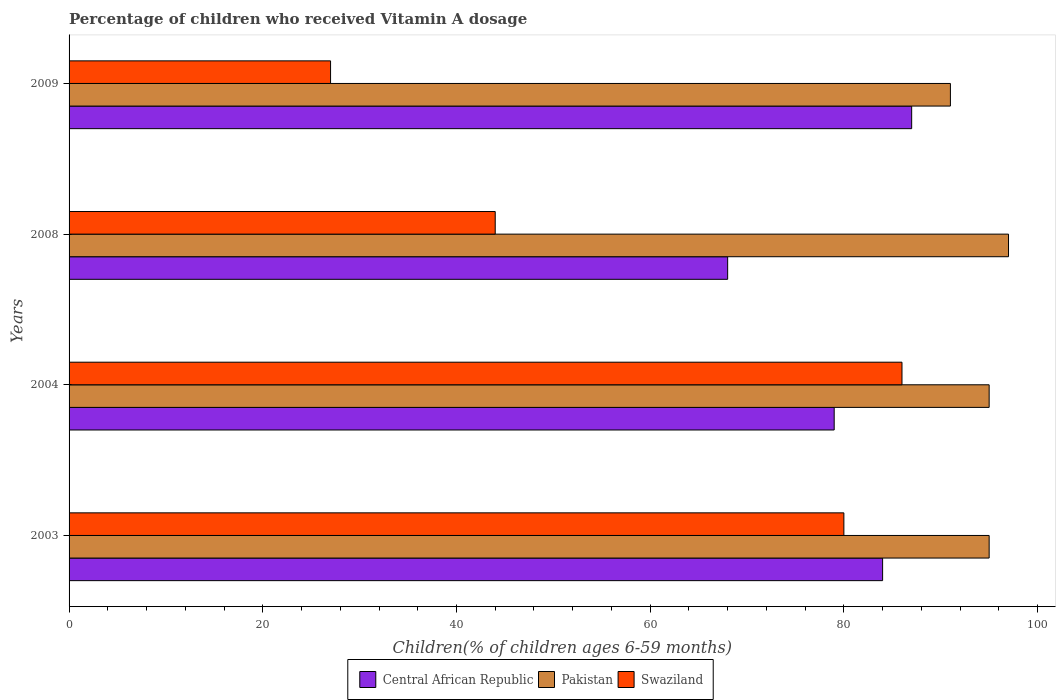In how many cases, is the number of bars for a given year not equal to the number of legend labels?
Give a very brief answer. 0. Across all years, what is the maximum percentage of children who received Vitamin A dosage in Pakistan?
Provide a succinct answer. 97. Across all years, what is the minimum percentage of children who received Vitamin A dosage in Central African Republic?
Offer a terse response. 68. What is the total percentage of children who received Vitamin A dosage in Central African Republic in the graph?
Offer a terse response. 318. What is the difference between the percentage of children who received Vitamin A dosage in Pakistan in 2003 and that in 2008?
Your answer should be very brief. -2. What is the average percentage of children who received Vitamin A dosage in Pakistan per year?
Ensure brevity in your answer.  94.5. In how many years, is the percentage of children who received Vitamin A dosage in Pakistan greater than 24 %?
Offer a very short reply. 4. What is the ratio of the percentage of children who received Vitamin A dosage in Pakistan in 2004 to that in 2009?
Offer a very short reply. 1.04. What is the difference between the highest and the second highest percentage of children who received Vitamin A dosage in Pakistan?
Your answer should be compact. 2. In how many years, is the percentage of children who received Vitamin A dosage in Swaziland greater than the average percentage of children who received Vitamin A dosage in Swaziland taken over all years?
Offer a terse response. 2. Is the sum of the percentage of children who received Vitamin A dosage in Pakistan in 2003 and 2004 greater than the maximum percentage of children who received Vitamin A dosage in Swaziland across all years?
Offer a terse response. Yes. What does the 1st bar from the top in 2009 represents?
Give a very brief answer. Swaziland. What does the 1st bar from the bottom in 2004 represents?
Make the answer very short. Central African Republic. Is it the case that in every year, the sum of the percentage of children who received Vitamin A dosage in Pakistan and percentage of children who received Vitamin A dosage in Central African Republic is greater than the percentage of children who received Vitamin A dosage in Swaziland?
Provide a succinct answer. Yes. Are all the bars in the graph horizontal?
Ensure brevity in your answer.  Yes. How many years are there in the graph?
Keep it short and to the point. 4. Are the values on the major ticks of X-axis written in scientific E-notation?
Your answer should be very brief. No. How are the legend labels stacked?
Provide a short and direct response. Horizontal. What is the title of the graph?
Offer a terse response. Percentage of children who received Vitamin A dosage. Does "Brazil" appear as one of the legend labels in the graph?
Provide a short and direct response. No. What is the label or title of the X-axis?
Give a very brief answer. Children(% of children ages 6-59 months). What is the label or title of the Y-axis?
Give a very brief answer. Years. What is the Children(% of children ages 6-59 months) in Central African Republic in 2003?
Offer a terse response. 84. What is the Children(% of children ages 6-59 months) of Pakistan in 2003?
Your answer should be very brief. 95. What is the Children(% of children ages 6-59 months) of Swaziland in 2003?
Your answer should be very brief. 80. What is the Children(% of children ages 6-59 months) in Central African Republic in 2004?
Offer a very short reply. 79. What is the Children(% of children ages 6-59 months) in Pakistan in 2004?
Give a very brief answer. 95. What is the Children(% of children ages 6-59 months) of Pakistan in 2008?
Your answer should be compact. 97. What is the Children(% of children ages 6-59 months) of Central African Republic in 2009?
Your response must be concise. 87. What is the Children(% of children ages 6-59 months) of Pakistan in 2009?
Keep it short and to the point. 91. Across all years, what is the maximum Children(% of children ages 6-59 months) of Pakistan?
Offer a terse response. 97. Across all years, what is the minimum Children(% of children ages 6-59 months) in Central African Republic?
Offer a very short reply. 68. Across all years, what is the minimum Children(% of children ages 6-59 months) in Pakistan?
Your response must be concise. 91. Across all years, what is the minimum Children(% of children ages 6-59 months) of Swaziland?
Make the answer very short. 27. What is the total Children(% of children ages 6-59 months) in Central African Republic in the graph?
Your answer should be very brief. 318. What is the total Children(% of children ages 6-59 months) of Pakistan in the graph?
Your answer should be very brief. 378. What is the total Children(% of children ages 6-59 months) in Swaziland in the graph?
Offer a very short reply. 237. What is the difference between the Children(% of children ages 6-59 months) of Pakistan in 2003 and that in 2004?
Keep it short and to the point. 0. What is the difference between the Children(% of children ages 6-59 months) in Swaziland in 2003 and that in 2004?
Give a very brief answer. -6. What is the difference between the Children(% of children ages 6-59 months) in Central African Republic in 2003 and that in 2009?
Offer a terse response. -3. What is the difference between the Children(% of children ages 6-59 months) of Pakistan in 2004 and that in 2008?
Your response must be concise. -2. What is the difference between the Children(% of children ages 6-59 months) of Swaziland in 2004 and that in 2008?
Your answer should be very brief. 42. What is the difference between the Children(% of children ages 6-59 months) in Pakistan in 2004 and that in 2009?
Provide a succinct answer. 4. What is the difference between the Children(% of children ages 6-59 months) in Swaziland in 2004 and that in 2009?
Keep it short and to the point. 59. What is the difference between the Children(% of children ages 6-59 months) in Pakistan in 2008 and that in 2009?
Your answer should be very brief. 6. What is the difference between the Children(% of children ages 6-59 months) of Swaziland in 2008 and that in 2009?
Provide a succinct answer. 17. What is the difference between the Children(% of children ages 6-59 months) in Central African Republic in 2003 and the Children(% of children ages 6-59 months) in Pakistan in 2004?
Ensure brevity in your answer.  -11. What is the difference between the Children(% of children ages 6-59 months) in Central African Republic in 2003 and the Children(% of children ages 6-59 months) in Swaziland in 2004?
Keep it short and to the point. -2. What is the difference between the Children(% of children ages 6-59 months) in Pakistan in 2003 and the Children(% of children ages 6-59 months) in Swaziland in 2004?
Give a very brief answer. 9. What is the difference between the Children(% of children ages 6-59 months) of Pakistan in 2003 and the Children(% of children ages 6-59 months) of Swaziland in 2008?
Your answer should be very brief. 51. What is the difference between the Children(% of children ages 6-59 months) of Central African Republic in 2003 and the Children(% of children ages 6-59 months) of Pakistan in 2009?
Keep it short and to the point. -7. What is the difference between the Children(% of children ages 6-59 months) in Central African Republic in 2004 and the Children(% of children ages 6-59 months) in Pakistan in 2008?
Provide a short and direct response. -18. What is the difference between the Children(% of children ages 6-59 months) of Central African Republic in 2004 and the Children(% of children ages 6-59 months) of Swaziland in 2008?
Give a very brief answer. 35. What is the difference between the Children(% of children ages 6-59 months) in Central African Republic in 2004 and the Children(% of children ages 6-59 months) in Pakistan in 2009?
Make the answer very short. -12. What is the difference between the Children(% of children ages 6-59 months) in Central African Republic in 2004 and the Children(% of children ages 6-59 months) in Swaziland in 2009?
Make the answer very short. 52. What is the difference between the Children(% of children ages 6-59 months) in Pakistan in 2004 and the Children(% of children ages 6-59 months) in Swaziland in 2009?
Give a very brief answer. 68. What is the difference between the Children(% of children ages 6-59 months) of Central African Republic in 2008 and the Children(% of children ages 6-59 months) of Swaziland in 2009?
Your answer should be very brief. 41. What is the difference between the Children(% of children ages 6-59 months) of Pakistan in 2008 and the Children(% of children ages 6-59 months) of Swaziland in 2009?
Give a very brief answer. 70. What is the average Children(% of children ages 6-59 months) in Central African Republic per year?
Keep it short and to the point. 79.5. What is the average Children(% of children ages 6-59 months) in Pakistan per year?
Make the answer very short. 94.5. What is the average Children(% of children ages 6-59 months) of Swaziland per year?
Ensure brevity in your answer.  59.25. In the year 2004, what is the difference between the Children(% of children ages 6-59 months) in Central African Republic and Children(% of children ages 6-59 months) in Pakistan?
Give a very brief answer. -16. In the year 2004, what is the difference between the Children(% of children ages 6-59 months) of Pakistan and Children(% of children ages 6-59 months) of Swaziland?
Your answer should be very brief. 9. In the year 2008, what is the difference between the Children(% of children ages 6-59 months) in Central African Republic and Children(% of children ages 6-59 months) in Swaziland?
Give a very brief answer. 24. In the year 2009, what is the difference between the Children(% of children ages 6-59 months) of Central African Republic and Children(% of children ages 6-59 months) of Swaziland?
Offer a terse response. 60. In the year 2009, what is the difference between the Children(% of children ages 6-59 months) in Pakistan and Children(% of children ages 6-59 months) in Swaziland?
Make the answer very short. 64. What is the ratio of the Children(% of children ages 6-59 months) in Central African Republic in 2003 to that in 2004?
Your answer should be very brief. 1.06. What is the ratio of the Children(% of children ages 6-59 months) in Pakistan in 2003 to that in 2004?
Offer a very short reply. 1. What is the ratio of the Children(% of children ages 6-59 months) of Swaziland in 2003 to that in 2004?
Offer a very short reply. 0.93. What is the ratio of the Children(% of children ages 6-59 months) in Central African Republic in 2003 to that in 2008?
Provide a succinct answer. 1.24. What is the ratio of the Children(% of children ages 6-59 months) of Pakistan in 2003 to that in 2008?
Provide a succinct answer. 0.98. What is the ratio of the Children(% of children ages 6-59 months) in Swaziland in 2003 to that in 2008?
Give a very brief answer. 1.82. What is the ratio of the Children(% of children ages 6-59 months) of Central African Republic in 2003 to that in 2009?
Give a very brief answer. 0.97. What is the ratio of the Children(% of children ages 6-59 months) of Pakistan in 2003 to that in 2009?
Provide a short and direct response. 1.04. What is the ratio of the Children(% of children ages 6-59 months) of Swaziland in 2003 to that in 2009?
Provide a succinct answer. 2.96. What is the ratio of the Children(% of children ages 6-59 months) in Central African Republic in 2004 to that in 2008?
Keep it short and to the point. 1.16. What is the ratio of the Children(% of children ages 6-59 months) in Pakistan in 2004 to that in 2008?
Your answer should be compact. 0.98. What is the ratio of the Children(% of children ages 6-59 months) of Swaziland in 2004 to that in 2008?
Make the answer very short. 1.95. What is the ratio of the Children(% of children ages 6-59 months) of Central African Republic in 2004 to that in 2009?
Keep it short and to the point. 0.91. What is the ratio of the Children(% of children ages 6-59 months) in Pakistan in 2004 to that in 2009?
Ensure brevity in your answer.  1.04. What is the ratio of the Children(% of children ages 6-59 months) in Swaziland in 2004 to that in 2009?
Keep it short and to the point. 3.19. What is the ratio of the Children(% of children ages 6-59 months) of Central African Republic in 2008 to that in 2009?
Offer a terse response. 0.78. What is the ratio of the Children(% of children ages 6-59 months) of Pakistan in 2008 to that in 2009?
Make the answer very short. 1.07. What is the ratio of the Children(% of children ages 6-59 months) in Swaziland in 2008 to that in 2009?
Offer a very short reply. 1.63. What is the difference between the highest and the second highest Children(% of children ages 6-59 months) of Central African Republic?
Provide a short and direct response. 3. What is the difference between the highest and the lowest Children(% of children ages 6-59 months) of Swaziland?
Offer a very short reply. 59. 